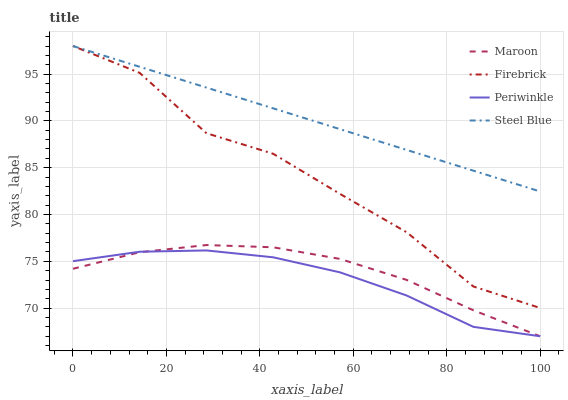Does Steel Blue have the minimum area under the curve?
Answer yes or no. No. Does Periwinkle have the maximum area under the curve?
Answer yes or no. No. Is Periwinkle the smoothest?
Answer yes or no. No. Is Periwinkle the roughest?
Answer yes or no. No. Does Steel Blue have the lowest value?
Answer yes or no. No. Does Periwinkle have the highest value?
Answer yes or no. No. Is Maroon less than Steel Blue?
Answer yes or no. Yes. Is Steel Blue greater than Periwinkle?
Answer yes or no. Yes. Does Maroon intersect Steel Blue?
Answer yes or no. No. 